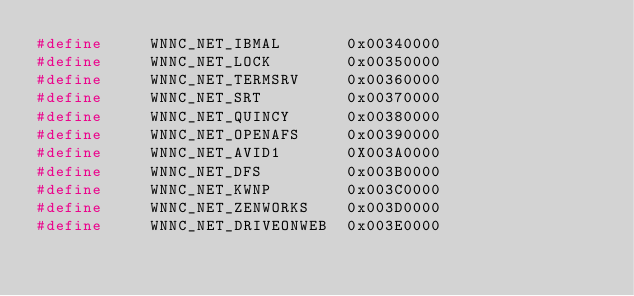<code> <loc_0><loc_0><loc_500><loc_500><_C_>#define     WNNC_NET_IBMAL       0x00340000
#define     WNNC_NET_LOCK        0x00350000
#define     WNNC_NET_TERMSRV     0x00360000
#define     WNNC_NET_SRT         0x00370000
#define     WNNC_NET_QUINCY      0x00380000
#define     WNNC_NET_OPENAFS     0x00390000
#define     WNNC_NET_AVID1       0X003A0000
#define     WNNC_NET_DFS         0x003B0000
#define     WNNC_NET_KWNP        0x003C0000
#define     WNNC_NET_ZENWORKS    0x003D0000
#define     WNNC_NET_DRIVEONWEB  0x003E0000</code> 